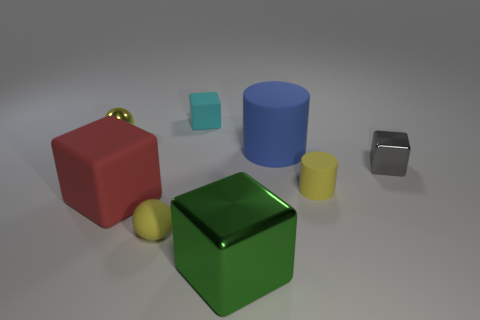Subtract all purple cubes. Subtract all cyan cylinders. How many cubes are left? 4 Add 2 yellow metal cylinders. How many objects exist? 10 Subtract all cylinders. How many objects are left? 6 Subtract all tiny cylinders. Subtract all tiny yellow metal things. How many objects are left? 6 Add 6 big blue matte cylinders. How many big blue matte cylinders are left? 7 Add 2 big spheres. How many big spheres exist? 2 Subtract 1 yellow spheres. How many objects are left? 7 